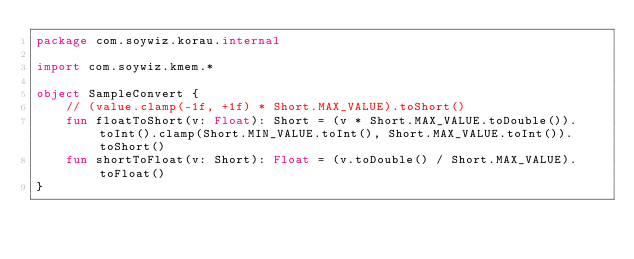Convert code to text. <code><loc_0><loc_0><loc_500><loc_500><_Kotlin_>package com.soywiz.korau.internal

import com.soywiz.kmem.*

object SampleConvert {
    // (value.clamp(-1f, +1f) * Short.MAX_VALUE).toShort()
    fun floatToShort(v: Float): Short = (v * Short.MAX_VALUE.toDouble()).toInt().clamp(Short.MIN_VALUE.toInt(), Short.MAX_VALUE.toInt()).toShort()
    fun shortToFloat(v: Short): Float = (v.toDouble() / Short.MAX_VALUE).toFloat()
}
</code> 